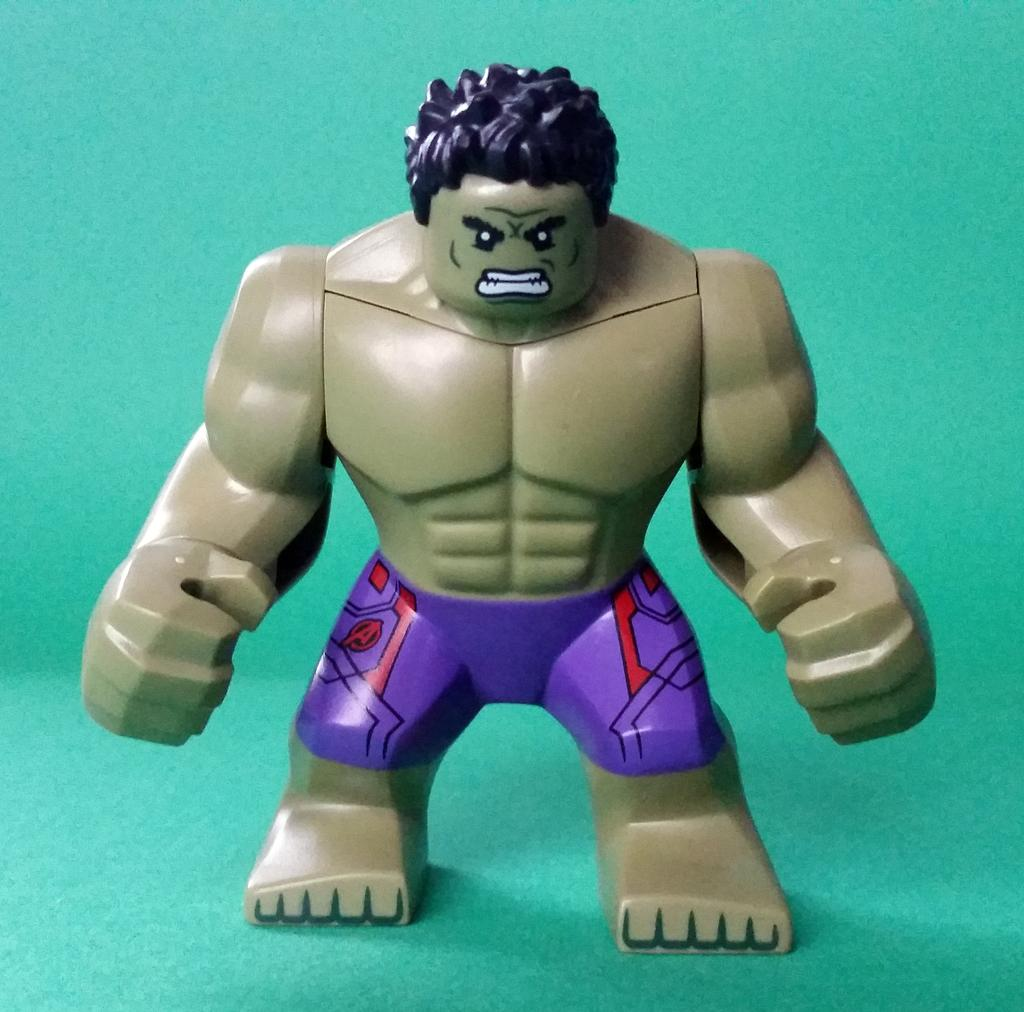What object can be seen in the image? There is a toy in the image. Where is the toy located? The toy is placed on a surface. How many people are walking on the trail in the image? There is no trail or people walking in the image; it only features a toy placed on a surface. 